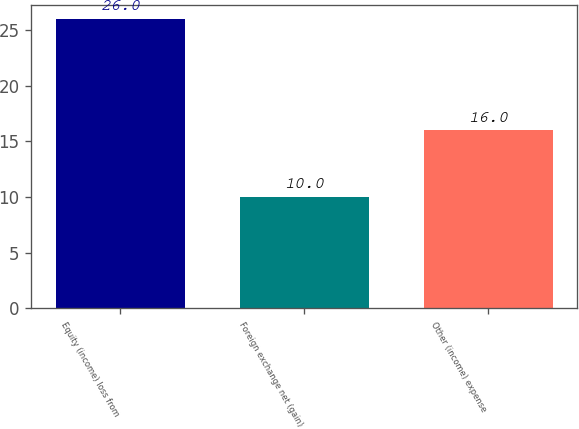<chart> <loc_0><loc_0><loc_500><loc_500><bar_chart><fcel>Equity (income) loss from<fcel>Foreign exchange net (gain)<fcel>Other (income) expense<nl><fcel>26<fcel>10<fcel>16<nl></chart> 